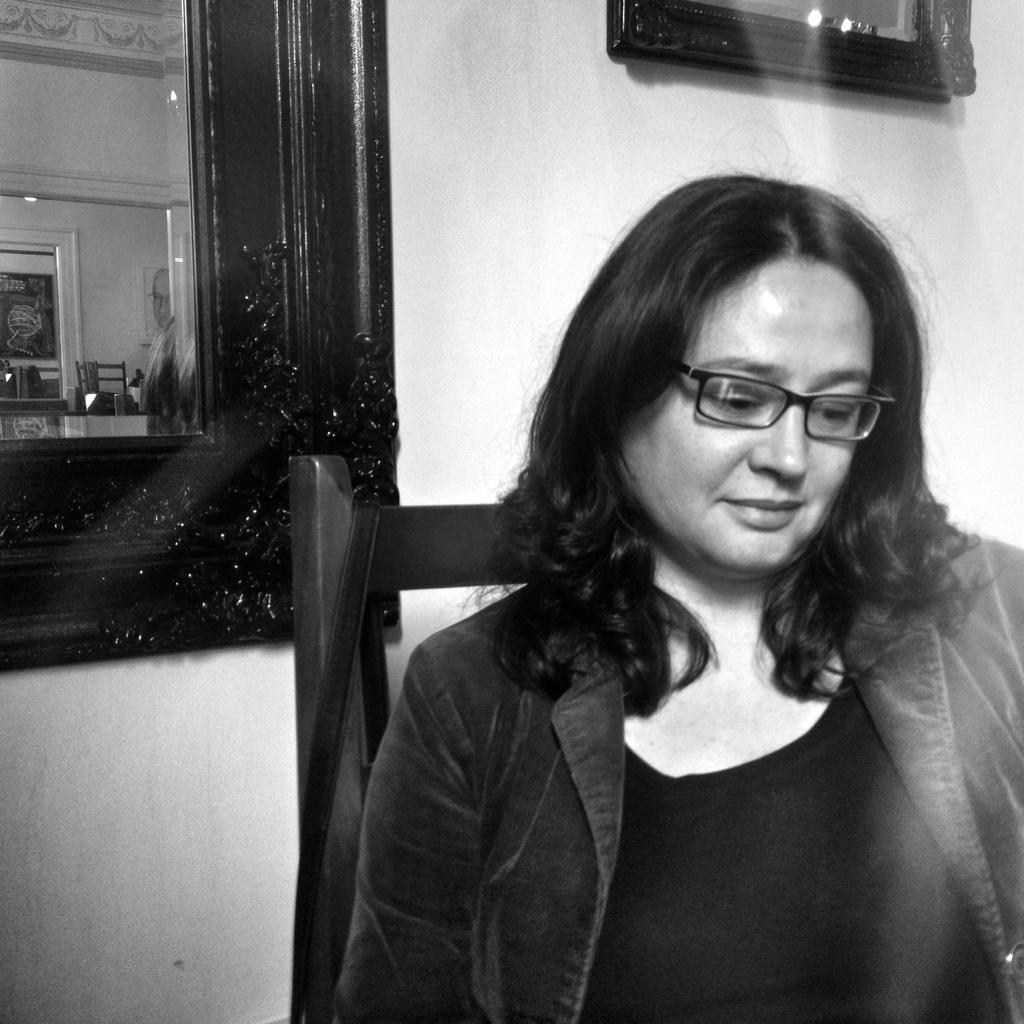Describe this image in one or two sentences. This is a black and white image. I can see a woman sitting on a chair. In the background, I can see a mirror and a frame attached to the wall. 